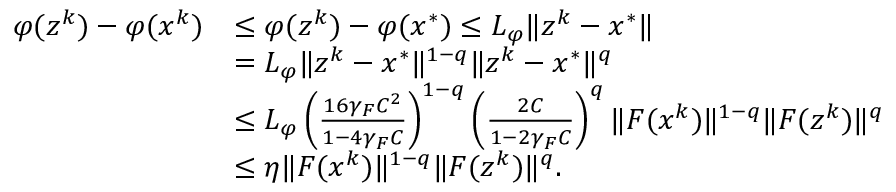Convert formula to latex. <formula><loc_0><loc_0><loc_500><loc_500>\begin{array} { r l } { \varphi ( z ^ { k } ) - \varphi ( x ^ { k } ) } & { \leq \varphi ( z ^ { k } ) - \varphi ( x ^ { * } ) \leq L _ { \varphi } \| z ^ { k } - x ^ { * } \| } \\ & { = L _ { \varphi } \| z ^ { k } - x ^ { * } \| ^ { 1 - q } \| z ^ { k } - x ^ { * } \| ^ { q } } \\ & { \leq L _ { \varphi } \left ( \frac { 1 6 \gamma _ { F } C ^ { 2 } } { 1 - 4 \gamma _ { F } C } \right ) ^ { 1 - q } \left ( \frac { 2 C } { 1 - 2 \gamma _ { F } C } \right ) ^ { q } \| F ( x ^ { k } ) \| ^ { 1 - q } \| F ( z ^ { k } ) \| ^ { q } } \\ & { \leq \eta \| F ( x ^ { k } ) \| ^ { 1 - q } \| F ( z ^ { k } ) \| ^ { q } . } \end{array}</formula> 